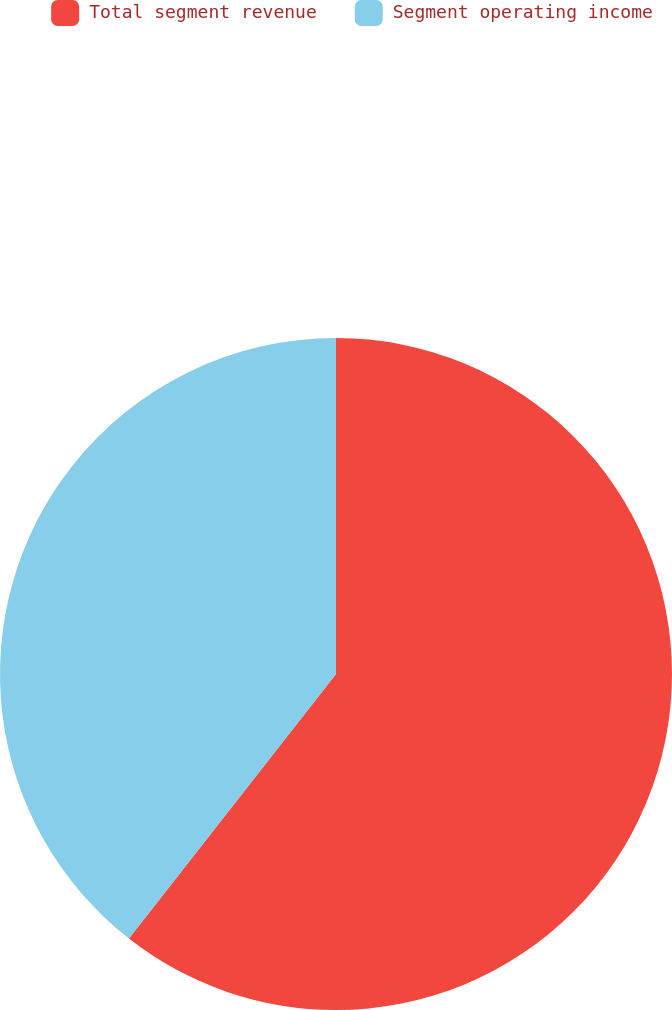Convert chart. <chart><loc_0><loc_0><loc_500><loc_500><pie_chart><fcel>Total segment revenue<fcel>Segment operating income<nl><fcel>60.57%<fcel>39.43%<nl></chart> 